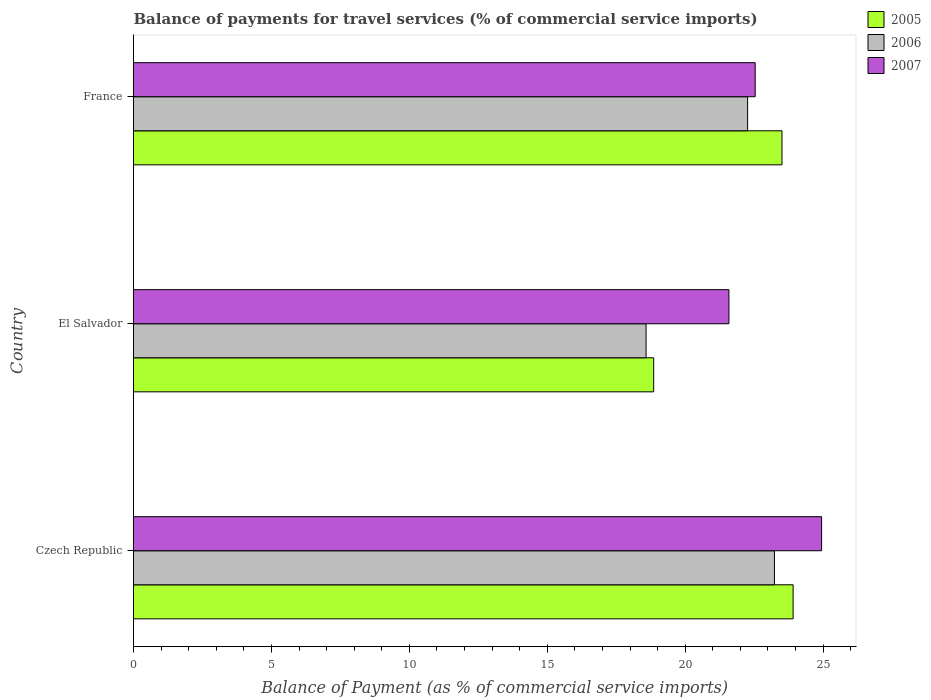How many different coloured bars are there?
Offer a very short reply. 3. How many bars are there on the 2nd tick from the top?
Keep it short and to the point. 3. How many bars are there on the 1st tick from the bottom?
Offer a very short reply. 3. What is the label of the 2nd group of bars from the top?
Offer a terse response. El Salvador. What is the balance of payments for travel services in 2006 in Czech Republic?
Your answer should be very brief. 23.24. Across all countries, what is the maximum balance of payments for travel services in 2007?
Your response must be concise. 24.94. Across all countries, what is the minimum balance of payments for travel services in 2005?
Offer a very short reply. 18.86. In which country was the balance of payments for travel services in 2006 maximum?
Provide a succinct answer. Czech Republic. In which country was the balance of payments for travel services in 2007 minimum?
Provide a short and direct response. El Salvador. What is the total balance of payments for travel services in 2006 in the graph?
Your answer should be very brief. 64.08. What is the difference between the balance of payments for travel services in 2007 in Czech Republic and that in France?
Make the answer very short. 2.41. What is the difference between the balance of payments for travel services in 2006 in Czech Republic and the balance of payments for travel services in 2007 in France?
Offer a very short reply. 0.7. What is the average balance of payments for travel services in 2005 per country?
Provide a short and direct response. 22.09. What is the difference between the balance of payments for travel services in 2006 and balance of payments for travel services in 2005 in Czech Republic?
Your response must be concise. -0.68. What is the ratio of the balance of payments for travel services in 2005 in El Salvador to that in France?
Your response must be concise. 0.8. Is the balance of payments for travel services in 2005 in Czech Republic less than that in El Salvador?
Ensure brevity in your answer.  No. Is the difference between the balance of payments for travel services in 2006 in Czech Republic and El Salvador greater than the difference between the balance of payments for travel services in 2005 in Czech Republic and El Salvador?
Give a very brief answer. No. What is the difference between the highest and the second highest balance of payments for travel services in 2006?
Give a very brief answer. 0.97. What is the difference between the highest and the lowest balance of payments for travel services in 2005?
Your answer should be very brief. 5.05. Is the sum of the balance of payments for travel services in 2005 in Czech Republic and France greater than the maximum balance of payments for travel services in 2006 across all countries?
Your answer should be very brief. Yes. What does the 1st bar from the top in El Salvador represents?
Keep it short and to the point. 2007. What does the 2nd bar from the bottom in France represents?
Provide a succinct answer. 2006. Are all the bars in the graph horizontal?
Ensure brevity in your answer.  Yes. How many countries are there in the graph?
Offer a very short reply. 3. Are the values on the major ticks of X-axis written in scientific E-notation?
Your response must be concise. No. Does the graph contain grids?
Ensure brevity in your answer.  No. What is the title of the graph?
Your answer should be compact. Balance of payments for travel services (% of commercial service imports). Does "2014" appear as one of the legend labels in the graph?
Offer a very short reply. No. What is the label or title of the X-axis?
Ensure brevity in your answer.  Balance of Payment (as % of commercial service imports). What is the Balance of Payment (as % of commercial service imports) of 2005 in Czech Republic?
Give a very brief answer. 23.91. What is the Balance of Payment (as % of commercial service imports) of 2006 in Czech Republic?
Give a very brief answer. 23.24. What is the Balance of Payment (as % of commercial service imports) in 2007 in Czech Republic?
Offer a very short reply. 24.94. What is the Balance of Payment (as % of commercial service imports) in 2005 in El Salvador?
Your answer should be very brief. 18.86. What is the Balance of Payment (as % of commercial service imports) in 2006 in El Salvador?
Your answer should be compact. 18.58. What is the Balance of Payment (as % of commercial service imports) in 2007 in El Salvador?
Provide a succinct answer. 21.59. What is the Balance of Payment (as % of commercial service imports) of 2005 in France?
Your answer should be compact. 23.51. What is the Balance of Payment (as % of commercial service imports) in 2006 in France?
Offer a very short reply. 22.26. What is the Balance of Payment (as % of commercial service imports) of 2007 in France?
Your answer should be compact. 22.54. Across all countries, what is the maximum Balance of Payment (as % of commercial service imports) in 2005?
Your answer should be compact. 23.91. Across all countries, what is the maximum Balance of Payment (as % of commercial service imports) in 2006?
Your response must be concise. 23.24. Across all countries, what is the maximum Balance of Payment (as % of commercial service imports) of 2007?
Make the answer very short. 24.94. Across all countries, what is the minimum Balance of Payment (as % of commercial service imports) of 2005?
Provide a succinct answer. 18.86. Across all countries, what is the minimum Balance of Payment (as % of commercial service imports) of 2006?
Provide a short and direct response. 18.58. Across all countries, what is the minimum Balance of Payment (as % of commercial service imports) in 2007?
Provide a succinct answer. 21.59. What is the total Balance of Payment (as % of commercial service imports) in 2005 in the graph?
Offer a very short reply. 66.28. What is the total Balance of Payment (as % of commercial service imports) of 2006 in the graph?
Your answer should be compact. 64.08. What is the total Balance of Payment (as % of commercial service imports) of 2007 in the graph?
Your response must be concise. 69.07. What is the difference between the Balance of Payment (as % of commercial service imports) in 2005 in Czech Republic and that in El Salvador?
Your answer should be very brief. 5.05. What is the difference between the Balance of Payment (as % of commercial service imports) of 2006 in Czech Republic and that in El Salvador?
Ensure brevity in your answer.  4.65. What is the difference between the Balance of Payment (as % of commercial service imports) in 2007 in Czech Republic and that in El Salvador?
Provide a short and direct response. 3.36. What is the difference between the Balance of Payment (as % of commercial service imports) in 2005 in Czech Republic and that in France?
Keep it short and to the point. 0.4. What is the difference between the Balance of Payment (as % of commercial service imports) in 2006 in Czech Republic and that in France?
Ensure brevity in your answer.  0.97. What is the difference between the Balance of Payment (as % of commercial service imports) in 2007 in Czech Republic and that in France?
Make the answer very short. 2.41. What is the difference between the Balance of Payment (as % of commercial service imports) in 2005 in El Salvador and that in France?
Your answer should be compact. -4.65. What is the difference between the Balance of Payment (as % of commercial service imports) of 2006 in El Salvador and that in France?
Ensure brevity in your answer.  -3.68. What is the difference between the Balance of Payment (as % of commercial service imports) of 2007 in El Salvador and that in France?
Your answer should be very brief. -0.95. What is the difference between the Balance of Payment (as % of commercial service imports) of 2005 in Czech Republic and the Balance of Payment (as % of commercial service imports) of 2006 in El Salvador?
Offer a very short reply. 5.33. What is the difference between the Balance of Payment (as % of commercial service imports) in 2005 in Czech Republic and the Balance of Payment (as % of commercial service imports) in 2007 in El Salvador?
Offer a terse response. 2.33. What is the difference between the Balance of Payment (as % of commercial service imports) in 2006 in Czech Republic and the Balance of Payment (as % of commercial service imports) in 2007 in El Salvador?
Ensure brevity in your answer.  1.65. What is the difference between the Balance of Payment (as % of commercial service imports) in 2005 in Czech Republic and the Balance of Payment (as % of commercial service imports) in 2006 in France?
Your answer should be compact. 1.65. What is the difference between the Balance of Payment (as % of commercial service imports) of 2005 in Czech Republic and the Balance of Payment (as % of commercial service imports) of 2007 in France?
Ensure brevity in your answer.  1.37. What is the difference between the Balance of Payment (as % of commercial service imports) in 2006 in Czech Republic and the Balance of Payment (as % of commercial service imports) in 2007 in France?
Ensure brevity in your answer.  0.7. What is the difference between the Balance of Payment (as % of commercial service imports) of 2005 in El Salvador and the Balance of Payment (as % of commercial service imports) of 2006 in France?
Provide a short and direct response. -3.41. What is the difference between the Balance of Payment (as % of commercial service imports) of 2005 in El Salvador and the Balance of Payment (as % of commercial service imports) of 2007 in France?
Offer a terse response. -3.68. What is the difference between the Balance of Payment (as % of commercial service imports) in 2006 in El Salvador and the Balance of Payment (as % of commercial service imports) in 2007 in France?
Your response must be concise. -3.96. What is the average Balance of Payment (as % of commercial service imports) of 2005 per country?
Your response must be concise. 22.09. What is the average Balance of Payment (as % of commercial service imports) of 2006 per country?
Your answer should be very brief. 21.36. What is the average Balance of Payment (as % of commercial service imports) in 2007 per country?
Ensure brevity in your answer.  23.02. What is the difference between the Balance of Payment (as % of commercial service imports) in 2005 and Balance of Payment (as % of commercial service imports) in 2006 in Czech Republic?
Your answer should be very brief. 0.68. What is the difference between the Balance of Payment (as % of commercial service imports) in 2005 and Balance of Payment (as % of commercial service imports) in 2007 in Czech Republic?
Your answer should be very brief. -1.03. What is the difference between the Balance of Payment (as % of commercial service imports) in 2006 and Balance of Payment (as % of commercial service imports) in 2007 in Czech Republic?
Your answer should be very brief. -1.71. What is the difference between the Balance of Payment (as % of commercial service imports) of 2005 and Balance of Payment (as % of commercial service imports) of 2006 in El Salvador?
Keep it short and to the point. 0.28. What is the difference between the Balance of Payment (as % of commercial service imports) in 2005 and Balance of Payment (as % of commercial service imports) in 2007 in El Salvador?
Your answer should be compact. -2.73. What is the difference between the Balance of Payment (as % of commercial service imports) in 2006 and Balance of Payment (as % of commercial service imports) in 2007 in El Salvador?
Offer a very short reply. -3. What is the difference between the Balance of Payment (as % of commercial service imports) of 2005 and Balance of Payment (as % of commercial service imports) of 2006 in France?
Keep it short and to the point. 1.25. What is the difference between the Balance of Payment (as % of commercial service imports) in 2005 and Balance of Payment (as % of commercial service imports) in 2007 in France?
Provide a succinct answer. 0.97. What is the difference between the Balance of Payment (as % of commercial service imports) of 2006 and Balance of Payment (as % of commercial service imports) of 2007 in France?
Ensure brevity in your answer.  -0.27. What is the ratio of the Balance of Payment (as % of commercial service imports) of 2005 in Czech Republic to that in El Salvador?
Provide a short and direct response. 1.27. What is the ratio of the Balance of Payment (as % of commercial service imports) in 2006 in Czech Republic to that in El Salvador?
Keep it short and to the point. 1.25. What is the ratio of the Balance of Payment (as % of commercial service imports) of 2007 in Czech Republic to that in El Salvador?
Offer a terse response. 1.16. What is the ratio of the Balance of Payment (as % of commercial service imports) in 2005 in Czech Republic to that in France?
Your answer should be very brief. 1.02. What is the ratio of the Balance of Payment (as % of commercial service imports) of 2006 in Czech Republic to that in France?
Your answer should be very brief. 1.04. What is the ratio of the Balance of Payment (as % of commercial service imports) of 2007 in Czech Republic to that in France?
Provide a succinct answer. 1.11. What is the ratio of the Balance of Payment (as % of commercial service imports) in 2005 in El Salvador to that in France?
Offer a terse response. 0.8. What is the ratio of the Balance of Payment (as % of commercial service imports) in 2006 in El Salvador to that in France?
Make the answer very short. 0.83. What is the ratio of the Balance of Payment (as % of commercial service imports) in 2007 in El Salvador to that in France?
Keep it short and to the point. 0.96. What is the difference between the highest and the second highest Balance of Payment (as % of commercial service imports) of 2005?
Offer a terse response. 0.4. What is the difference between the highest and the second highest Balance of Payment (as % of commercial service imports) in 2006?
Offer a terse response. 0.97. What is the difference between the highest and the second highest Balance of Payment (as % of commercial service imports) in 2007?
Keep it short and to the point. 2.41. What is the difference between the highest and the lowest Balance of Payment (as % of commercial service imports) in 2005?
Provide a succinct answer. 5.05. What is the difference between the highest and the lowest Balance of Payment (as % of commercial service imports) in 2006?
Offer a terse response. 4.65. What is the difference between the highest and the lowest Balance of Payment (as % of commercial service imports) in 2007?
Your response must be concise. 3.36. 